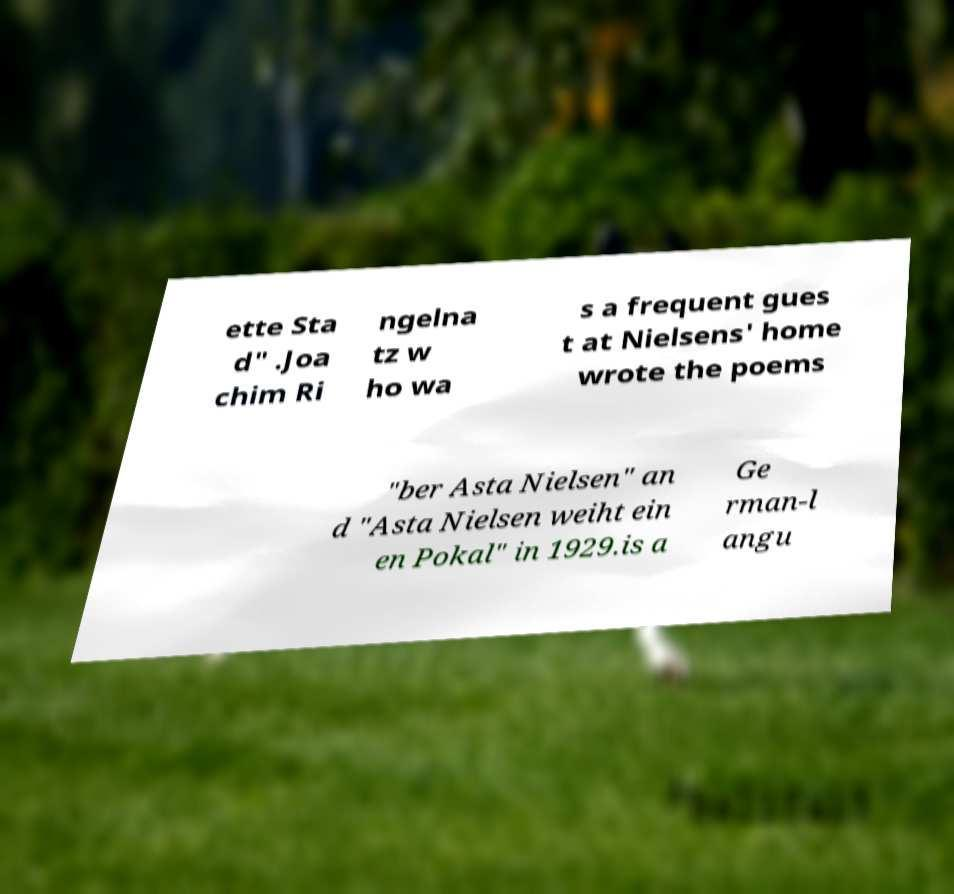I need the written content from this picture converted into text. Can you do that? ette Sta d" .Joa chim Ri ngelna tz w ho wa s a frequent gues t at Nielsens' home wrote the poems "ber Asta Nielsen" an d "Asta Nielsen weiht ein en Pokal" in 1929.is a Ge rman-l angu 